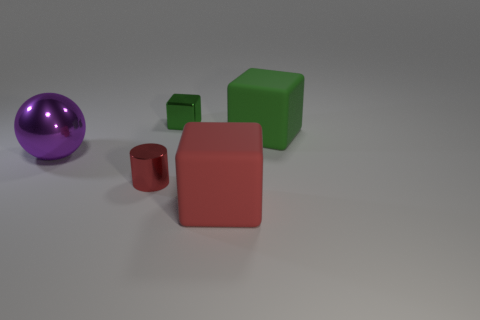Are there more big red things that are in front of the green metal block than metal spheres on the right side of the purple shiny object?
Your answer should be compact. Yes. Is there a small red sphere made of the same material as the red block?
Your answer should be compact. No. There is a thing that is left of the small green shiny object and behind the small red cylinder; what is its material?
Keep it short and to the point. Metal. The large shiny sphere is what color?
Your response must be concise. Purple. How many small metal objects are the same shape as the red rubber object?
Offer a very short reply. 1. Is the material of the block in front of the purple shiny ball the same as the green block to the left of the green matte block?
Ensure brevity in your answer.  No. There is a red thing behind the red thing to the right of the small green metal thing; how big is it?
Give a very brief answer. Small. There is another big object that is the same shape as the large red object; what is its material?
Your answer should be compact. Rubber. Does the small green metallic object that is right of the tiny cylinder have the same shape as the tiny shiny thing that is in front of the big green object?
Your answer should be very brief. No. Is the number of small balls greater than the number of small green shiny objects?
Provide a short and direct response. No. 